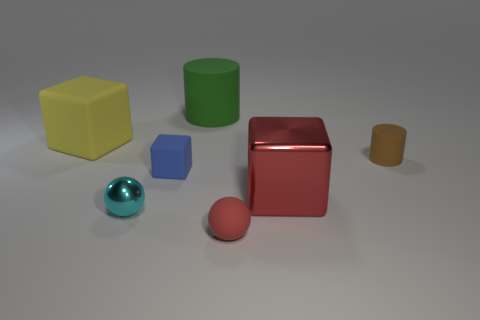There is a object that is the same color as the tiny matte sphere; what material is it?
Your answer should be very brief. Metal. What color is the tiny shiny sphere?
Your response must be concise. Cyan. What is the shape of the large thing on the right side of the large matte cylinder behind the matte object that is to the right of the tiny red matte object?
Give a very brief answer. Cube. What is the material of the big cube that is left of the ball on the right side of the blue matte cube?
Provide a succinct answer. Rubber. What is the shape of the object that is the same material as the big red cube?
Your response must be concise. Sphere. Are there any other things that have the same shape as the blue rubber thing?
Keep it short and to the point. Yes. How many matte cylinders are in front of the blue object?
Provide a succinct answer. 0. Are there any large purple cubes?
Give a very brief answer. No. What is the color of the cylinder that is to the left of the small rubber object to the right of the large block that is in front of the yellow rubber object?
Provide a succinct answer. Green. Is there a large rubber cylinder that is in front of the block on the right side of the tiny blue cube?
Ensure brevity in your answer.  No. 